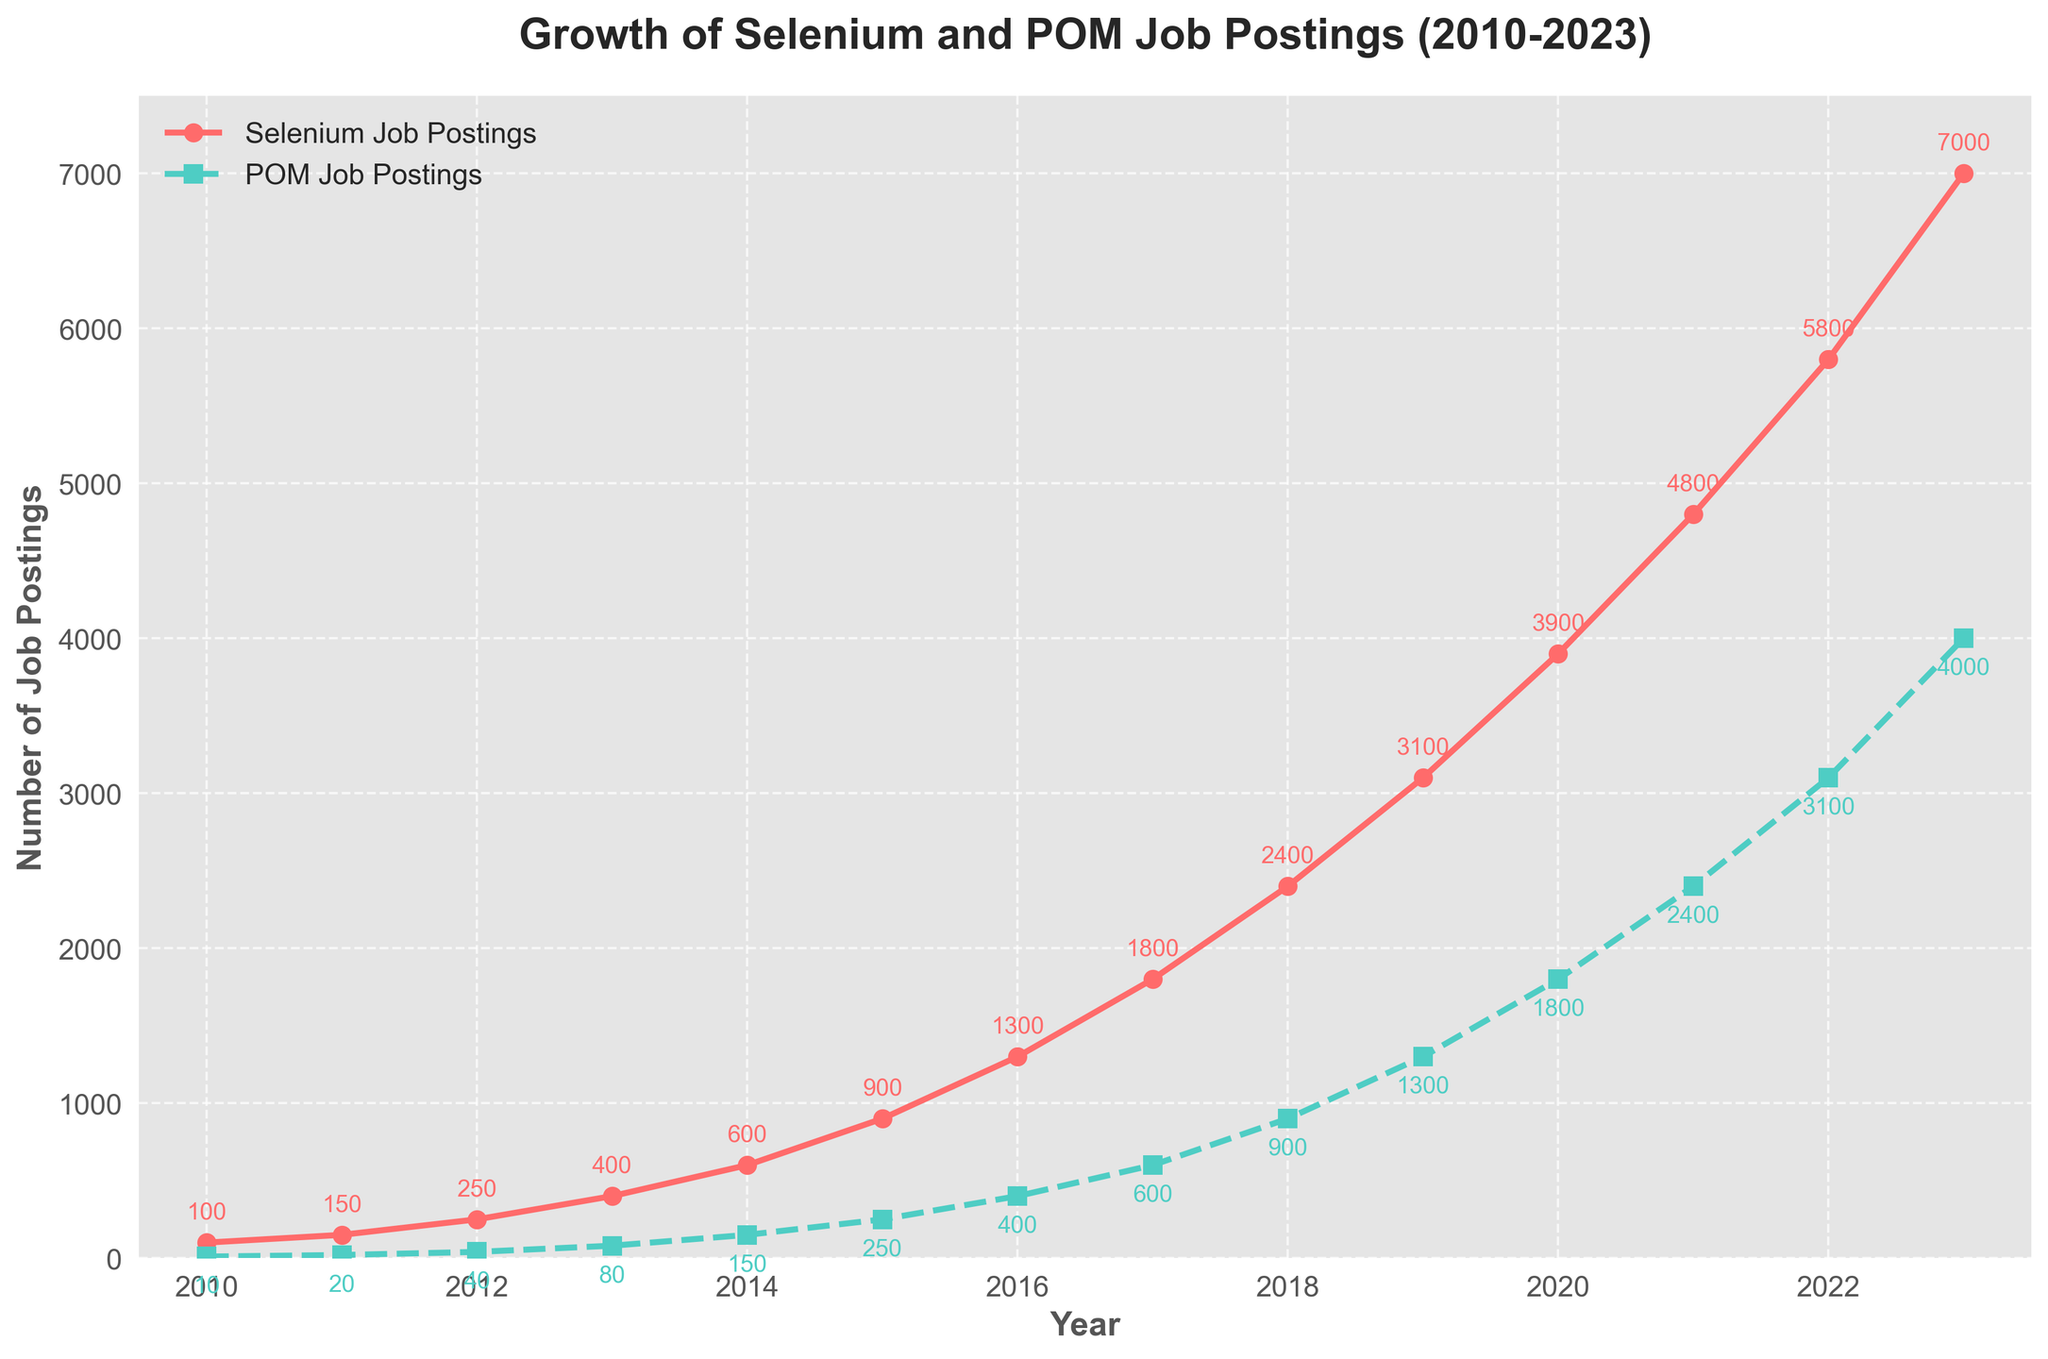What is the general trend of job postings for Selenium skills from 2010 to 2023? The number of job postings for Selenium skills shows an upward trend from 2010 to 2023, increasing from 100 to 7000.
Answer: Upward How many more job postings required POM skills in 2023 compared to 2010? To find the difference, subtract the number of POM job postings in 2010 from the number in 2023. 4000 (in 2023) - 10 (in 2010) = 3990.
Answer: 3990 In which year did the number of Selenium job postings first surpass 1000? The number of Selenium job postings first surpassed 1000 in 2016 when it reached 1300.
Answer: 2016 By how much did Selenium job postings increase from 2019 to 2023? Subtract the number of Selenium job postings in 2019 from the number in 2023. 7000 (in 2023) - 3100 (in 2019) = 3900.
Answer: 3900 What is the difference between the number of Selenium job postings and POM job postings in 2022? Subtract the number of POM job postings from Selenium job postings in 2022. 5800 - 3100 = 2700.
Answer: 2700 Which year showed the highest increase in POM job postings compared to the previous year? The highest increase is the difference that is largest when compared year-to-year. The largest increase is from 2021 to 2022: 3100 - 2400 = 700.
Answer: 2022 How does the growth rate of Selenium job postings compare to POM job postings between 2010 and 2023? Calculate the growth rate by finding the percentage increase for both. Selenium: (7000 - 100) / 100 = 6900%, POM: (4000 - 10) / 10 = 39900%. Selenium has grown significantly, but POM shows an even higher percentage increase.
Answer: Higher for POM What does the intersection of the lines representing Selenium and POM job postings imply? The lines intersect where the number of job postings for Selenium equals job postings for POM, suggesting equal demand at that point if they did intersect. However, in this chart, they do not intersect; demand for Selenium has always been higher.
Answer: Selenium always higher 